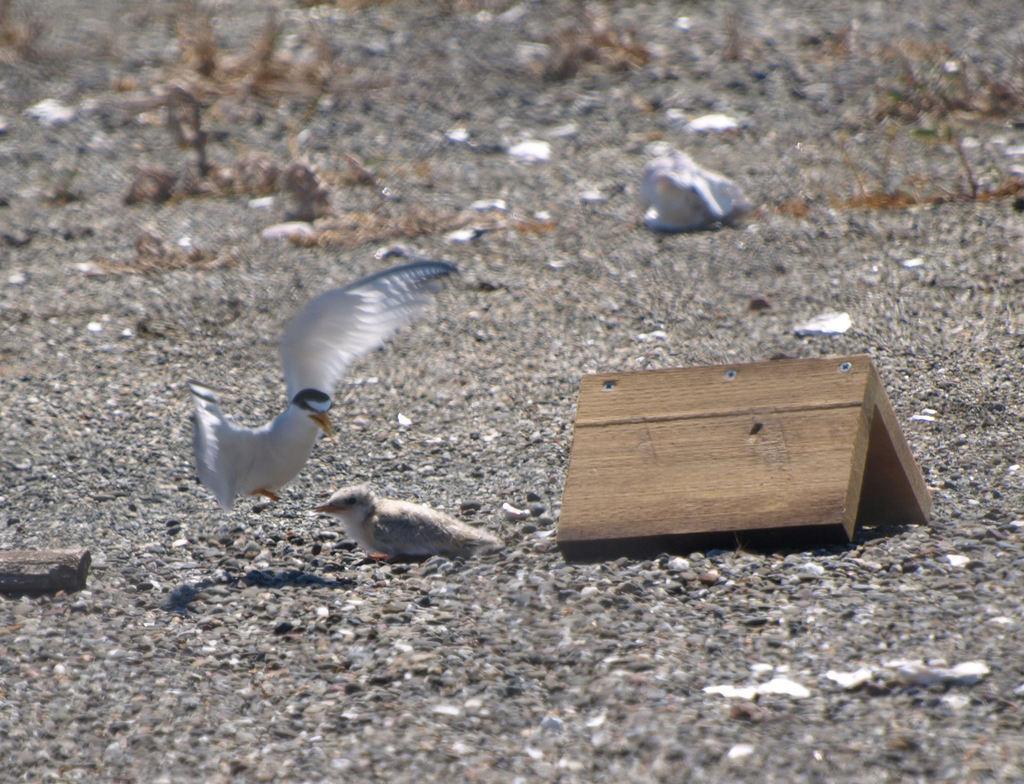Could you give a brief overview of what you see in this image? In this image we can see birds, ground, and a wooden object. 